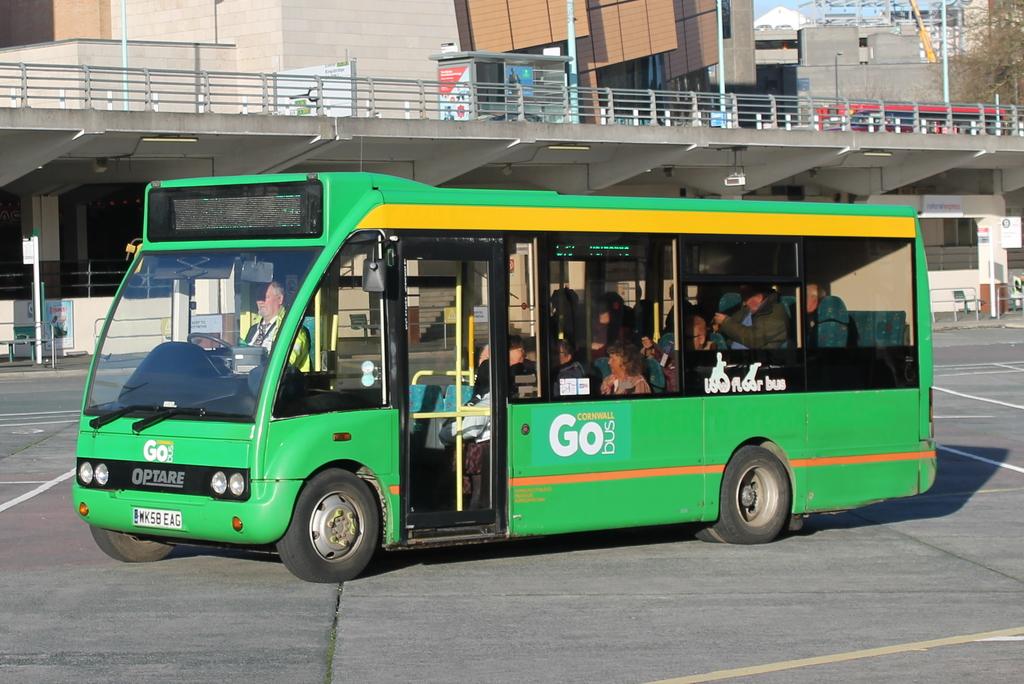What is the model of this bus?
Give a very brief answer. Optare. 